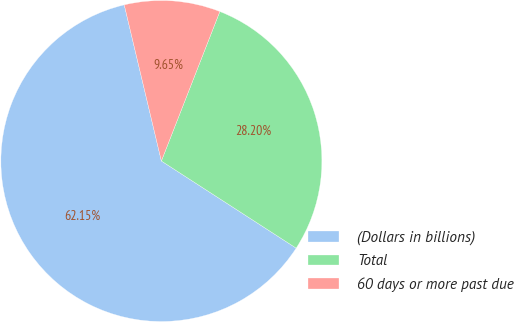Convert chart to OTSL. <chart><loc_0><loc_0><loc_500><loc_500><pie_chart><fcel>(Dollars in billions)<fcel>Total<fcel>60 days or more past due<nl><fcel>62.15%<fcel>28.2%<fcel>9.65%<nl></chart> 